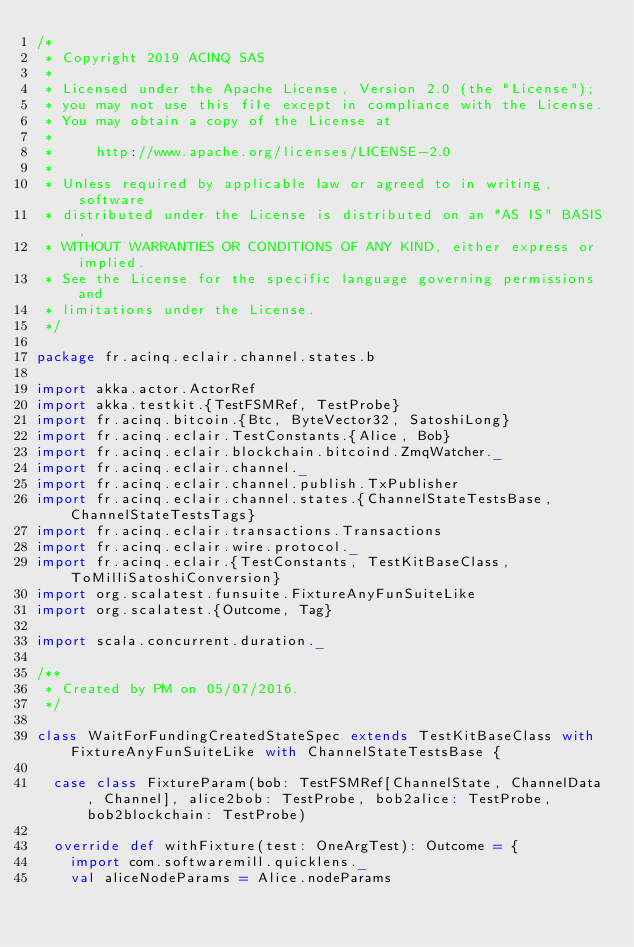Convert code to text. <code><loc_0><loc_0><loc_500><loc_500><_Scala_>/*
 * Copyright 2019 ACINQ SAS
 *
 * Licensed under the Apache License, Version 2.0 (the "License");
 * you may not use this file except in compliance with the License.
 * You may obtain a copy of the License at
 *
 *     http://www.apache.org/licenses/LICENSE-2.0
 *
 * Unless required by applicable law or agreed to in writing, software
 * distributed under the License is distributed on an "AS IS" BASIS,
 * WITHOUT WARRANTIES OR CONDITIONS OF ANY KIND, either express or implied.
 * See the License for the specific language governing permissions and
 * limitations under the License.
 */

package fr.acinq.eclair.channel.states.b

import akka.actor.ActorRef
import akka.testkit.{TestFSMRef, TestProbe}
import fr.acinq.bitcoin.{Btc, ByteVector32, SatoshiLong}
import fr.acinq.eclair.TestConstants.{Alice, Bob}
import fr.acinq.eclair.blockchain.bitcoind.ZmqWatcher._
import fr.acinq.eclair.channel._
import fr.acinq.eclair.channel.publish.TxPublisher
import fr.acinq.eclair.channel.states.{ChannelStateTestsBase, ChannelStateTestsTags}
import fr.acinq.eclair.transactions.Transactions
import fr.acinq.eclair.wire.protocol._
import fr.acinq.eclair.{TestConstants, TestKitBaseClass, ToMilliSatoshiConversion}
import org.scalatest.funsuite.FixtureAnyFunSuiteLike
import org.scalatest.{Outcome, Tag}

import scala.concurrent.duration._

/**
 * Created by PM on 05/07/2016.
 */

class WaitForFundingCreatedStateSpec extends TestKitBaseClass with FixtureAnyFunSuiteLike with ChannelStateTestsBase {

  case class FixtureParam(bob: TestFSMRef[ChannelState, ChannelData, Channel], alice2bob: TestProbe, bob2alice: TestProbe, bob2blockchain: TestProbe)

  override def withFixture(test: OneArgTest): Outcome = {
    import com.softwaremill.quicklens._
    val aliceNodeParams = Alice.nodeParams</code> 